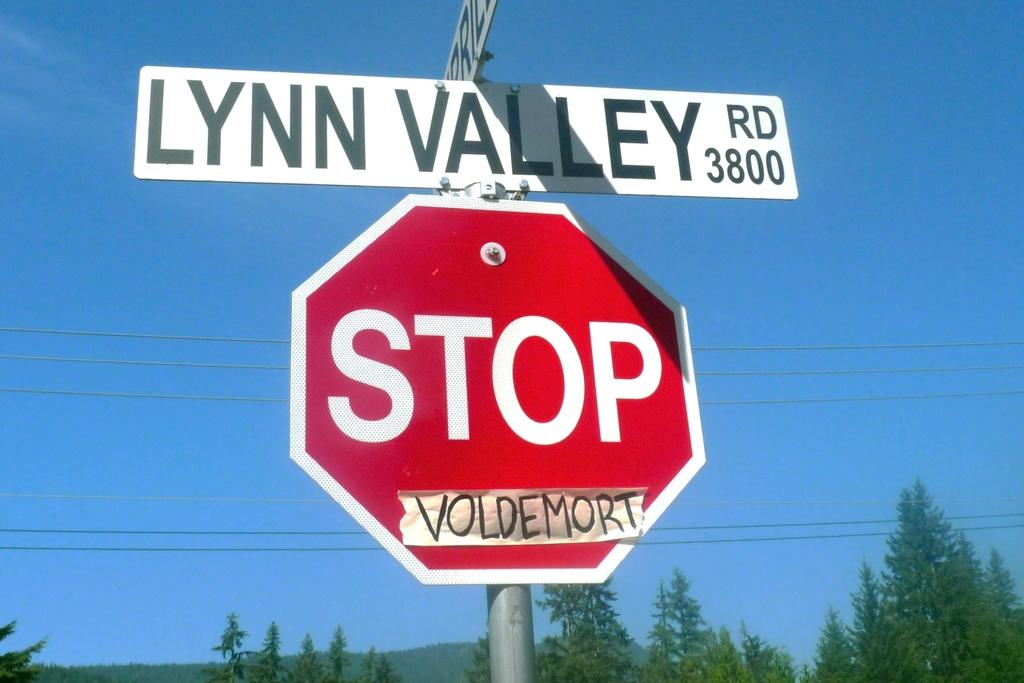<image>
Write a terse but informative summary of the picture. A stop sign is attached to a pole beneath two perpendicular street signs. 